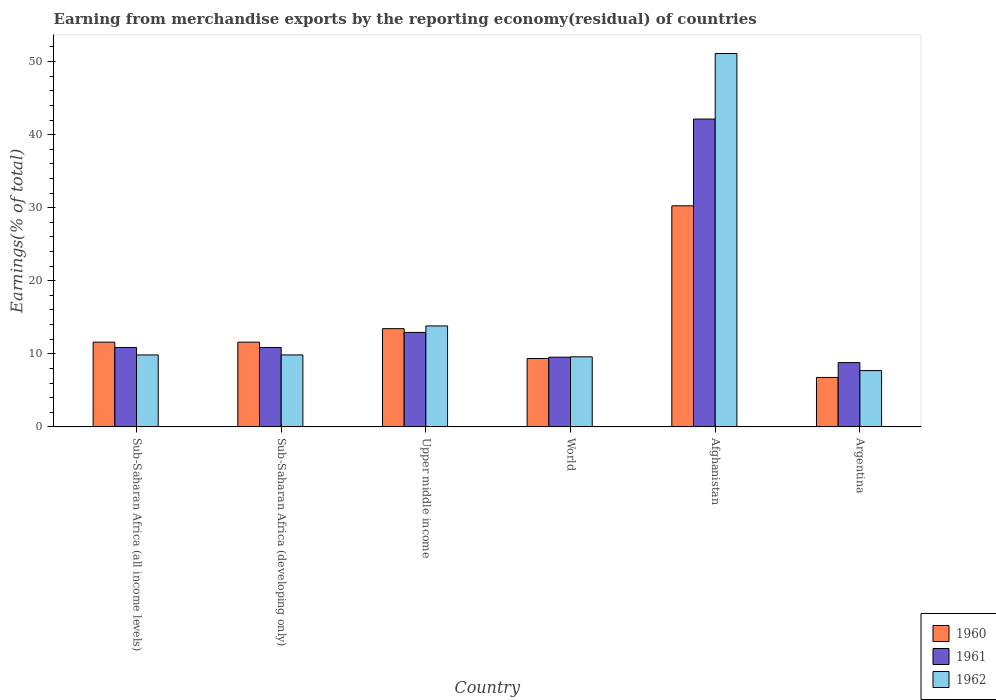How many different coloured bars are there?
Your response must be concise. 3. Are the number of bars per tick equal to the number of legend labels?
Ensure brevity in your answer.  Yes. Are the number of bars on each tick of the X-axis equal?
Give a very brief answer. Yes. How many bars are there on the 3rd tick from the right?
Your response must be concise. 3. What is the label of the 1st group of bars from the left?
Your response must be concise. Sub-Saharan Africa (all income levels). What is the percentage of amount earned from merchandise exports in 1961 in Upper middle income?
Give a very brief answer. 12.93. Across all countries, what is the maximum percentage of amount earned from merchandise exports in 1962?
Ensure brevity in your answer.  51.1. Across all countries, what is the minimum percentage of amount earned from merchandise exports in 1961?
Your response must be concise. 8.79. In which country was the percentage of amount earned from merchandise exports in 1961 maximum?
Make the answer very short. Afghanistan. What is the total percentage of amount earned from merchandise exports in 1960 in the graph?
Your response must be concise. 83.02. What is the difference between the percentage of amount earned from merchandise exports in 1960 in Afghanistan and that in Sub-Saharan Africa (all income levels)?
Offer a terse response. 18.66. What is the difference between the percentage of amount earned from merchandise exports in 1960 in Afghanistan and the percentage of amount earned from merchandise exports in 1962 in Argentina?
Offer a very short reply. 22.56. What is the average percentage of amount earned from merchandise exports in 1960 per country?
Your answer should be very brief. 13.84. What is the difference between the percentage of amount earned from merchandise exports of/in 1960 and percentage of amount earned from merchandise exports of/in 1961 in Upper middle income?
Ensure brevity in your answer.  0.51. In how many countries, is the percentage of amount earned from merchandise exports in 1962 greater than 36 %?
Keep it short and to the point. 1. What is the ratio of the percentage of amount earned from merchandise exports in 1962 in Argentina to that in World?
Offer a terse response. 0.8. Is the difference between the percentage of amount earned from merchandise exports in 1960 in Argentina and Sub-Saharan Africa (all income levels) greater than the difference between the percentage of amount earned from merchandise exports in 1961 in Argentina and Sub-Saharan Africa (all income levels)?
Provide a short and direct response. No. What is the difference between the highest and the second highest percentage of amount earned from merchandise exports in 1962?
Your response must be concise. -41.25. What is the difference between the highest and the lowest percentage of amount earned from merchandise exports in 1960?
Provide a short and direct response. 23.5. What does the 2nd bar from the left in Upper middle income represents?
Offer a very short reply. 1961. Are all the bars in the graph horizontal?
Your response must be concise. No. How many countries are there in the graph?
Provide a short and direct response. 6. What is the difference between two consecutive major ticks on the Y-axis?
Offer a very short reply. 10. Are the values on the major ticks of Y-axis written in scientific E-notation?
Offer a very short reply. No. Does the graph contain grids?
Ensure brevity in your answer.  No. How many legend labels are there?
Offer a terse response. 3. What is the title of the graph?
Your answer should be very brief. Earning from merchandise exports by the reporting economy(residual) of countries. Does "1979" appear as one of the legend labels in the graph?
Make the answer very short. No. What is the label or title of the Y-axis?
Your answer should be very brief. Earnings(% of total). What is the Earnings(% of total) in 1960 in Sub-Saharan Africa (all income levels)?
Make the answer very short. 11.6. What is the Earnings(% of total) in 1961 in Sub-Saharan Africa (all income levels)?
Ensure brevity in your answer.  10.87. What is the Earnings(% of total) of 1962 in Sub-Saharan Africa (all income levels)?
Keep it short and to the point. 9.85. What is the Earnings(% of total) in 1960 in Sub-Saharan Africa (developing only)?
Keep it short and to the point. 11.6. What is the Earnings(% of total) in 1961 in Sub-Saharan Africa (developing only)?
Provide a short and direct response. 10.87. What is the Earnings(% of total) of 1962 in Sub-Saharan Africa (developing only)?
Your answer should be very brief. 9.85. What is the Earnings(% of total) of 1960 in Upper middle income?
Keep it short and to the point. 13.44. What is the Earnings(% of total) of 1961 in Upper middle income?
Offer a very short reply. 12.93. What is the Earnings(% of total) of 1962 in Upper middle income?
Your response must be concise. 13.82. What is the Earnings(% of total) in 1960 in World?
Provide a succinct answer. 9.36. What is the Earnings(% of total) in 1961 in World?
Provide a short and direct response. 9.54. What is the Earnings(% of total) of 1962 in World?
Your answer should be very brief. 9.59. What is the Earnings(% of total) of 1960 in Afghanistan?
Make the answer very short. 30.26. What is the Earnings(% of total) in 1961 in Afghanistan?
Offer a very short reply. 42.13. What is the Earnings(% of total) of 1962 in Afghanistan?
Your response must be concise. 51.1. What is the Earnings(% of total) in 1960 in Argentina?
Your answer should be very brief. 6.76. What is the Earnings(% of total) in 1961 in Argentina?
Your answer should be compact. 8.79. What is the Earnings(% of total) in 1962 in Argentina?
Give a very brief answer. 7.7. Across all countries, what is the maximum Earnings(% of total) of 1960?
Make the answer very short. 30.26. Across all countries, what is the maximum Earnings(% of total) in 1961?
Ensure brevity in your answer.  42.13. Across all countries, what is the maximum Earnings(% of total) in 1962?
Your response must be concise. 51.1. Across all countries, what is the minimum Earnings(% of total) of 1960?
Provide a short and direct response. 6.76. Across all countries, what is the minimum Earnings(% of total) of 1961?
Make the answer very short. 8.79. Across all countries, what is the minimum Earnings(% of total) of 1962?
Your answer should be very brief. 7.7. What is the total Earnings(% of total) of 1960 in the graph?
Give a very brief answer. 83.02. What is the total Earnings(% of total) in 1961 in the graph?
Provide a short and direct response. 95.13. What is the total Earnings(% of total) of 1962 in the graph?
Offer a terse response. 101.91. What is the difference between the Earnings(% of total) of 1960 in Sub-Saharan Africa (all income levels) and that in Sub-Saharan Africa (developing only)?
Provide a short and direct response. 0. What is the difference between the Earnings(% of total) in 1961 in Sub-Saharan Africa (all income levels) and that in Sub-Saharan Africa (developing only)?
Keep it short and to the point. 0. What is the difference between the Earnings(% of total) in 1960 in Sub-Saharan Africa (all income levels) and that in Upper middle income?
Provide a succinct answer. -1.85. What is the difference between the Earnings(% of total) of 1961 in Sub-Saharan Africa (all income levels) and that in Upper middle income?
Keep it short and to the point. -2.06. What is the difference between the Earnings(% of total) in 1962 in Sub-Saharan Africa (all income levels) and that in Upper middle income?
Keep it short and to the point. -3.97. What is the difference between the Earnings(% of total) in 1960 in Sub-Saharan Africa (all income levels) and that in World?
Your answer should be very brief. 2.24. What is the difference between the Earnings(% of total) in 1961 in Sub-Saharan Africa (all income levels) and that in World?
Provide a short and direct response. 1.33. What is the difference between the Earnings(% of total) in 1962 in Sub-Saharan Africa (all income levels) and that in World?
Ensure brevity in your answer.  0.26. What is the difference between the Earnings(% of total) in 1960 in Sub-Saharan Africa (all income levels) and that in Afghanistan?
Your response must be concise. -18.66. What is the difference between the Earnings(% of total) in 1961 in Sub-Saharan Africa (all income levels) and that in Afghanistan?
Provide a succinct answer. -31.27. What is the difference between the Earnings(% of total) in 1962 in Sub-Saharan Africa (all income levels) and that in Afghanistan?
Keep it short and to the point. -41.25. What is the difference between the Earnings(% of total) in 1960 in Sub-Saharan Africa (all income levels) and that in Argentina?
Your answer should be compact. 4.83. What is the difference between the Earnings(% of total) of 1961 in Sub-Saharan Africa (all income levels) and that in Argentina?
Keep it short and to the point. 2.07. What is the difference between the Earnings(% of total) in 1962 in Sub-Saharan Africa (all income levels) and that in Argentina?
Offer a very short reply. 2.15. What is the difference between the Earnings(% of total) in 1960 in Sub-Saharan Africa (developing only) and that in Upper middle income?
Offer a terse response. -1.85. What is the difference between the Earnings(% of total) of 1961 in Sub-Saharan Africa (developing only) and that in Upper middle income?
Give a very brief answer. -2.06. What is the difference between the Earnings(% of total) in 1962 in Sub-Saharan Africa (developing only) and that in Upper middle income?
Give a very brief answer. -3.97. What is the difference between the Earnings(% of total) in 1960 in Sub-Saharan Africa (developing only) and that in World?
Offer a very short reply. 2.24. What is the difference between the Earnings(% of total) in 1961 in Sub-Saharan Africa (developing only) and that in World?
Offer a very short reply. 1.33. What is the difference between the Earnings(% of total) in 1962 in Sub-Saharan Africa (developing only) and that in World?
Provide a succinct answer. 0.26. What is the difference between the Earnings(% of total) in 1960 in Sub-Saharan Africa (developing only) and that in Afghanistan?
Keep it short and to the point. -18.66. What is the difference between the Earnings(% of total) of 1961 in Sub-Saharan Africa (developing only) and that in Afghanistan?
Ensure brevity in your answer.  -31.27. What is the difference between the Earnings(% of total) of 1962 in Sub-Saharan Africa (developing only) and that in Afghanistan?
Give a very brief answer. -41.25. What is the difference between the Earnings(% of total) in 1960 in Sub-Saharan Africa (developing only) and that in Argentina?
Make the answer very short. 4.83. What is the difference between the Earnings(% of total) in 1961 in Sub-Saharan Africa (developing only) and that in Argentina?
Your response must be concise. 2.07. What is the difference between the Earnings(% of total) in 1962 in Sub-Saharan Africa (developing only) and that in Argentina?
Provide a short and direct response. 2.15. What is the difference between the Earnings(% of total) in 1960 in Upper middle income and that in World?
Provide a short and direct response. 4.08. What is the difference between the Earnings(% of total) of 1961 in Upper middle income and that in World?
Your response must be concise. 3.39. What is the difference between the Earnings(% of total) of 1962 in Upper middle income and that in World?
Provide a succinct answer. 4.23. What is the difference between the Earnings(% of total) in 1960 in Upper middle income and that in Afghanistan?
Make the answer very short. -16.82. What is the difference between the Earnings(% of total) in 1961 in Upper middle income and that in Afghanistan?
Ensure brevity in your answer.  -29.2. What is the difference between the Earnings(% of total) in 1962 in Upper middle income and that in Afghanistan?
Your response must be concise. -37.29. What is the difference between the Earnings(% of total) in 1960 in Upper middle income and that in Argentina?
Provide a short and direct response. 6.68. What is the difference between the Earnings(% of total) of 1961 in Upper middle income and that in Argentina?
Provide a succinct answer. 4.14. What is the difference between the Earnings(% of total) of 1962 in Upper middle income and that in Argentina?
Offer a terse response. 6.12. What is the difference between the Earnings(% of total) of 1960 in World and that in Afghanistan?
Your answer should be very brief. -20.9. What is the difference between the Earnings(% of total) of 1961 in World and that in Afghanistan?
Give a very brief answer. -32.6. What is the difference between the Earnings(% of total) in 1962 in World and that in Afghanistan?
Offer a terse response. -41.51. What is the difference between the Earnings(% of total) of 1960 in World and that in Argentina?
Your answer should be very brief. 2.59. What is the difference between the Earnings(% of total) in 1961 in World and that in Argentina?
Keep it short and to the point. 0.74. What is the difference between the Earnings(% of total) of 1962 in World and that in Argentina?
Offer a terse response. 1.89. What is the difference between the Earnings(% of total) in 1960 in Afghanistan and that in Argentina?
Provide a succinct answer. 23.5. What is the difference between the Earnings(% of total) of 1961 in Afghanistan and that in Argentina?
Keep it short and to the point. 33.34. What is the difference between the Earnings(% of total) in 1962 in Afghanistan and that in Argentina?
Give a very brief answer. 43.4. What is the difference between the Earnings(% of total) in 1960 in Sub-Saharan Africa (all income levels) and the Earnings(% of total) in 1961 in Sub-Saharan Africa (developing only)?
Keep it short and to the point. 0.73. What is the difference between the Earnings(% of total) of 1960 in Sub-Saharan Africa (all income levels) and the Earnings(% of total) of 1962 in Sub-Saharan Africa (developing only)?
Your response must be concise. 1.75. What is the difference between the Earnings(% of total) in 1961 in Sub-Saharan Africa (all income levels) and the Earnings(% of total) in 1962 in Sub-Saharan Africa (developing only)?
Provide a short and direct response. 1.02. What is the difference between the Earnings(% of total) of 1960 in Sub-Saharan Africa (all income levels) and the Earnings(% of total) of 1961 in Upper middle income?
Keep it short and to the point. -1.33. What is the difference between the Earnings(% of total) in 1960 in Sub-Saharan Africa (all income levels) and the Earnings(% of total) in 1962 in Upper middle income?
Keep it short and to the point. -2.22. What is the difference between the Earnings(% of total) in 1961 in Sub-Saharan Africa (all income levels) and the Earnings(% of total) in 1962 in Upper middle income?
Your response must be concise. -2.95. What is the difference between the Earnings(% of total) of 1960 in Sub-Saharan Africa (all income levels) and the Earnings(% of total) of 1961 in World?
Your answer should be compact. 2.06. What is the difference between the Earnings(% of total) in 1960 in Sub-Saharan Africa (all income levels) and the Earnings(% of total) in 1962 in World?
Offer a very short reply. 2.01. What is the difference between the Earnings(% of total) in 1961 in Sub-Saharan Africa (all income levels) and the Earnings(% of total) in 1962 in World?
Make the answer very short. 1.28. What is the difference between the Earnings(% of total) of 1960 in Sub-Saharan Africa (all income levels) and the Earnings(% of total) of 1961 in Afghanistan?
Your response must be concise. -30.54. What is the difference between the Earnings(% of total) of 1960 in Sub-Saharan Africa (all income levels) and the Earnings(% of total) of 1962 in Afghanistan?
Make the answer very short. -39.51. What is the difference between the Earnings(% of total) in 1961 in Sub-Saharan Africa (all income levels) and the Earnings(% of total) in 1962 in Afghanistan?
Provide a succinct answer. -40.24. What is the difference between the Earnings(% of total) in 1960 in Sub-Saharan Africa (all income levels) and the Earnings(% of total) in 1961 in Argentina?
Provide a short and direct response. 2.8. What is the difference between the Earnings(% of total) of 1960 in Sub-Saharan Africa (all income levels) and the Earnings(% of total) of 1962 in Argentina?
Give a very brief answer. 3.9. What is the difference between the Earnings(% of total) in 1961 in Sub-Saharan Africa (all income levels) and the Earnings(% of total) in 1962 in Argentina?
Your answer should be compact. 3.17. What is the difference between the Earnings(% of total) of 1960 in Sub-Saharan Africa (developing only) and the Earnings(% of total) of 1961 in Upper middle income?
Make the answer very short. -1.33. What is the difference between the Earnings(% of total) of 1960 in Sub-Saharan Africa (developing only) and the Earnings(% of total) of 1962 in Upper middle income?
Make the answer very short. -2.22. What is the difference between the Earnings(% of total) in 1961 in Sub-Saharan Africa (developing only) and the Earnings(% of total) in 1962 in Upper middle income?
Ensure brevity in your answer.  -2.95. What is the difference between the Earnings(% of total) in 1960 in Sub-Saharan Africa (developing only) and the Earnings(% of total) in 1961 in World?
Give a very brief answer. 2.06. What is the difference between the Earnings(% of total) in 1960 in Sub-Saharan Africa (developing only) and the Earnings(% of total) in 1962 in World?
Give a very brief answer. 2.01. What is the difference between the Earnings(% of total) in 1961 in Sub-Saharan Africa (developing only) and the Earnings(% of total) in 1962 in World?
Offer a very short reply. 1.28. What is the difference between the Earnings(% of total) of 1960 in Sub-Saharan Africa (developing only) and the Earnings(% of total) of 1961 in Afghanistan?
Keep it short and to the point. -30.54. What is the difference between the Earnings(% of total) in 1960 in Sub-Saharan Africa (developing only) and the Earnings(% of total) in 1962 in Afghanistan?
Your answer should be very brief. -39.51. What is the difference between the Earnings(% of total) of 1961 in Sub-Saharan Africa (developing only) and the Earnings(% of total) of 1962 in Afghanistan?
Ensure brevity in your answer.  -40.24. What is the difference between the Earnings(% of total) of 1960 in Sub-Saharan Africa (developing only) and the Earnings(% of total) of 1961 in Argentina?
Give a very brief answer. 2.8. What is the difference between the Earnings(% of total) of 1960 in Sub-Saharan Africa (developing only) and the Earnings(% of total) of 1962 in Argentina?
Your answer should be very brief. 3.9. What is the difference between the Earnings(% of total) in 1961 in Sub-Saharan Africa (developing only) and the Earnings(% of total) in 1962 in Argentina?
Your response must be concise. 3.17. What is the difference between the Earnings(% of total) of 1960 in Upper middle income and the Earnings(% of total) of 1961 in World?
Your answer should be very brief. 3.9. What is the difference between the Earnings(% of total) of 1960 in Upper middle income and the Earnings(% of total) of 1962 in World?
Your answer should be compact. 3.85. What is the difference between the Earnings(% of total) of 1961 in Upper middle income and the Earnings(% of total) of 1962 in World?
Keep it short and to the point. 3.34. What is the difference between the Earnings(% of total) of 1960 in Upper middle income and the Earnings(% of total) of 1961 in Afghanistan?
Offer a terse response. -28.69. What is the difference between the Earnings(% of total) in 1960 in Upper middle income and the Earnings(% of total) in 1962 in Afghanistan?
Your answer should be compact. -37.66. What is the difference between the Earnings(% of total) of 1961 in Upper middle income and the Earnings(% of total) of 1962 in Afghanistan?
Make the answer very short. -38.17. What is the difference between the Earnings(% of total) of 1960 in Upper middle income and the Earnings(% of total) of 1961 in Argentina?
Keep it short and to the point. 4.65. What is the difference between the Earnings(% of total) in 1960 in Upper middle income and the Earnings(% of total) in 1962 in Argentina?
Offer a very short reply. 5.74. What is the difference between the Earnings(% of total) in 1961 in Upper middle income and the Earnings(% of total) in 1962 in Argentina?
Ensure brevity in your answer.  5.23. What is the difference between the Earnings(% of total) of 1960 in World and the Earnings(% of total) of 1961 in Afghanistan?
Provide a short and direct response. -32.78. What is the difference between the Earnings(% of total) in 1960 in World and the Earnings(% of total) in 1962 in Afghanistan?
Offer a very short reply. -41.74. What is the difference between the Earnings(% of total) in 1961 in World and the Earnings(% of total) in 1962 in Afghanistan?
Give a very brief answer. -41.56. What is the difference between the Earnings(% of total) of 1960 in World and the Earnings(% of total) of 1961 in Argentina?
Offer a terse response. 0.56. What is the difference between the Earnings(% of total) in 1960 in World and the Earnings(% of total) in 1962 in Argentina?
Ensure brevity in your answer.  1.66. What is the difference between the Earnings(% of total) of 1961 in World and the Earnings(% of total) of 1962 in Argentina?
Give a very brief answer. 1.84. What is the difference between the Earnings(% of total) of 1960 in Afghanistan and the Earnings(% of total) of 1961 in Argentina?
Offer a terse response. 21.47. What is the difference between the Earnings(% of total) of 1960 in Afghanistan and the Earnings(% of total) of 1962 in Argentina?
Keep it short and to the point. 22.56. What is the difference between the Earnings(% of total) in 1961 in Afghanistan and the Earnings(% of total) in 1962 in Argentina?
Ensure brevity in your answer.  34.43. What is the average Earnings(% of total) in 1960 per country?
Provide a short and direct response. 13.84. What is the average Earnings(% of total) of 1961 per country?
Your response must be concise. 15.86. What is the average Earnings(% of total) in 1962 per country?
Give a very brief answer. 16.98. What is the difference between the Earnings(% of total) in 1960 and Earnings(% of total) in 1961 in Sub-Saharan Africa (all income levels)?
Make the answer very short. 0.73. What is the difference between the Earnings(% of total) of 1960 and Earnings(% of total) of 1962 in Sub-Saharan Africa (all income levels)?
Your response must be concise. 1.75. What is the difference between the Earnings(% of total) in 1961 and Earnings(% of total) in 1962 in Sub-Saharan Africa (all income levels)?
Your response must be concise. 1.02. What is the difference between the Earnings(% of total) of 1960 and Earnings(% of total) of 1961 in Sub-Saharan Africa (developing only)?
Your response must be concise. 0.73. What is the difference between the Earnings(% of total) in 1960 and Earnings(% of total) in 1962 in Sub-Saharan Africa (developing only)?
Your answer should be very brief. 1.75. What is the difference between the Earnings(% of total) in 1961 and Earnings(% of total) in 1962 in Sub-Saharan Africa (developing only)?
Give a very brief answer. 1.02. What is the difference between the Earnings(% of total) of 1960 and Earnings(% of total) of 1961 in Upper middle income?
Offer a terse response. 0.51. What is the difference between the Earnings(% of total) of 1960 and Earnings(% of total) of 1962 in Upper middle income?
Provide a short and direct response. -0.38. What is the difference between the Earnings(% of total) in 1961 and Earnings(% of total) in 1962 in Upper middle income?
Make the answer very short. -0.89. What is the difference between the Earnings(% of total) in 1960 and Earnings(% of total) in 1961 in World?
Make the answer very short. -0.18. What is the difference between the Earnings(% of total) of 1960 and Earnings(% of total) of 1962 in World?
Offer a terse response. -0.23. What is the difference between the Earnings(% of total) of 1961 and Earnings(% of total) of 1962 in World?
Make the answer very short. -0.05. What is the difference between the Earnings(% of total) of 1960 and Earnings(% of total) of 1961 in Afghanistan?
Provide a short and direct response. -11.87. What is the difference between the Earnings(% of total) of 1960 and Earnings(% of total) of 1962 in Afghanistan?
Make the answer very short. -20.84. What is the difference between the Earnings(% of total) of 1961 and Earnings(% of total) of 1962 in Afghanistan?
Your answer should be very brief. -8.97. What is the difference between the Earnings(% of total) of 1960 and Earnings(% of total) of 1961 in Argentina?
Your answer should be compact. -2.03. What is the difference between the Earnings(% of total) of 1960 and Earnings(% of total) of 1962 in Argentina?
Your answer should be very brief. -0.94. What is the difference between the Earnings(% of total) of 1961 and Earnings(% of total) of 1962 in Argentina?
Your response must be concise. 1.09. What is the ratio of the Earnings(% of total) in 1960 in Sub-Saharan Africa (all income levels) to that in Upper middle income?
Offer a terse response. 0.86. What is the ratio of the Earnings(% of total) of 1961 in Sub-Saharan Africa (all income levels) to that in Upper middle income?
Offer a terse response. 0.84. What is the ratio of the Earnings(% of total) in 1962 in Sub-Saharan Africa (all income levels) to that in Upper middle income?
Your response must be concise. 0.71. What is the ratio of the Earnings(% of total) in 1960 in Sub-Saharan Africa (all income levels) to that in World?
Make the answer very short. 1.24. What is the ratio of the Earnings(% of total) of 1961 in Sub-Saharan Africa (all income levels) to that in World?
Provide a succinct answer. 1.14. What is the ratio of the Earnings(% of total) in 1960 in Sub-Saharan Africa (all income levels) to that in Afghanistan?
Provide a succinct answer. 0.38. What is the ratio of the Earnings(% of total) in 1961 in Sub-Saharan Africa (all income levels) to that in Afghanistan?
Give a very brief answer. 0.26. What is the ratio of the Earnings(% of total) of 1962 in Sub-Saharan Africa (all income levels) to that in Afghanistan?
Make the answer very short. 0.19. What is the ratio of the Earnings(% of total) in 1960 in Sub-Saharan Africa (all income levels) to that in Argentina?
Ensure brevity in your answer.  1.71. What is the ratio of the Earnings(% of total) of 1961 in Sub-Saharan Africa (all income levels) to that in Argentina?
Provide a succinct answer. 1.24. What is the ratio of the Earnings(% of total) of 1962 in Sub-Saharan Africa (all income levels) to that in Argentina?
Your response must be concise. 1.28. What is the ratio of the Earnings(% of total) of 1960 in Sub-Saharan Africa (developing only) to that in Upper middle income?
Provide a short and direct response. 0.86. What is the ratio of the Earnings(% of total) of 1961 in Sub-Saharan Africa (developing only) to that in Upper middle income?
Give a very brief answer. 0.84. What is the ratio of the Earnings(% of total) in 1962 in Sub-Saharan Africa (developing only) to that in Upper middle income?
Offer a very short reply. 0.71. What is the ratio of the Earnings(% of total) in 1960 in Sub-Saharan Africa (developing only) to that in World?
Ensure brevity in your answer.  1.24. What is the ratio of the Earnings(% of total) in 1961 in Sub-Saharan Africa (developing only) to that in World?
Your response must be concise. 1.14. What is the ratio of the Earnings(% of total) of 1962 in Sub-Saharan Africa (developing only) to that in World?
Make the answer very short. 1.03. What is the ratio of the Earnings(% of total) in 1960 in Sub-Saharan Africa (developing only) to that in Afghanistan?
Your answer should be very brief. 0.38. What is the ratio of the Earnings(% of total) of 1961 in Sub-Saharan Africa (developing only) to that in Afghanistan?
Offer a very short reply. 0.26. What is the ratio of the Earnings(% of total) in 1962 in Sub-Saharan Africa (developing only) to that in Afghanistan?
Ensure brevity in your answer.  0.19. What is the ratio of the Earnings(% of total) of 1960 in Sub-Saharan Africa (developing only) to that in Argentina?
Provide a succinct answer. 1.71. What is the ratio of the Earnings(% of total) of 1961 in Sub-Saharan Africa (developing only) to that in Argentina?
Ensure brevity in your answer.  1.24. What is the ratio of the Earnings(% of total) in 1962 in Sub-Saharan Africa (developing only) to that in Argentina?
Ensure brevity in your answer.  1.28. What is the ratio of the Earnings(% of total) in 1960 in Upper middle income to that in World?
Your response must be concise. 1.44. What is the ratio of the Earnings(% of total) in 1961 in Upper middle income to that in World?
Your answer should be compact. 1.36. What is the ratio of the Earnings(% of total) of 1962 in Upper middle income to that in World?
Make the answer very short. 1.44. What is the ratio of the Earnings(% of total) of 1960 in Upper middle income to that in Afghanistan?
Your response must be concise. 0.44. What is the ratio of the Earnings(% of total) in 1961 in Upper middle income to that in Afghanistan?
Your answer should be very brief. 0.31. What is the ratio of the Earnings(% of total) in 1962 in Upper middle income to that in Afghanistan?
Your answer should be very brief. 0.27. What is the ratio of the Earnings(% of total) of 1960 in Upper middle income to that in Argentina?
Ensure brevity in your answer.  1.99. What is the ratio of the Earnings(% of total) of 1961 in Upper middle income to that in Argentina?
Keep it short and to the point. 1.47. What is the ratio of the Earnings(% of total) in 1962 in Upper middle income to that in Argentina?
Provide a short and direct response. 1.79. What is the ratio of the Earnings(% of total) in 1960 in World to that in Afghanistan?
Offer a terse response. 0.31. What is the ratio of the Earnings(% of total) in 1961 in World to that in Afghanistan?
Offer a very short reply. 0.23. What is the ratio of the Earnings(% of total) in 1962 in World to that in Afghanistan?
Offer a very short reply. 0.19. What is the ratio of the Earnings(% of total) in 1960 in World to that in Argentina?
Ensure brevity in your answer.  1.38. What is the ratio of the Earnings(% of total) in 1961 in World to that in Argentina?
Ensure brevity in your answer.  1.08. What is the ratio of the Earnings(% of total) of 1962 in World to that in Argentina?
Your response must be concise. 1.25. What is the ratio of the Earnings(% of total) in 1960 in Afghanistan to that in Argentina?
Provide a succinct answer. 4.47. What is the ratio of the Earnings(% of total) in 1961 in Afghanistan to that in Argentina?
Your answer should be compact. 4.79. What is the ratio of the Earnings(% of total) in 1962 in Afghanistan to that in Argentina?
Your response must be concise. 6.64. What is the difference between the highest and the second highest Earnings(% of total) of 1960?
Give a very brief answer. 16.82. What is the difference between the highest and the second highest Earnings(% of total) in 1961?
Make the answer very short. 29.2. What is the difference between the highest and the second highest Earnings(% of total) in 1962?
Offer a terse response. 37.29. What is the difference between the highest and the lowest Earnings(% of total) of 1960?
Ensure brevity in your answer.  23.5. What is the difference between the highest and the lowest Earnings(% of total) in 1961?
Give a very brief answer. 33.34. What is the difference between the highest and the lowest Earnings(% of total) of 1962?
Offer a terse response. 43.4. 